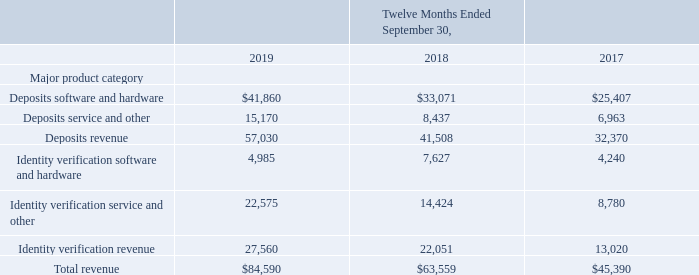Disaggregation of Revenue
The following table presents the Company's revenue disaggregated by major product category (amounts in thousands):
Software and hardware revenue is generated from on premise software license sales, as well as sales of hardware scanner boxes and on premise appliance products. Service and other revenue is generated from the sale of transactional SaaS products and services, maintenance associated with the sale of software and hardware, and consulting and professional services.
How is software and hardware revenue generated from? On premise software license sales, as well as sales of hardware scanner boxes and on premise appliance products. What is the value of Deposits software and hardware in fiscal 2019?
Answer scale should be: thousand. $41,860. What is the total revenue in the fiscal year 2018?
Answer scale should be: thousand. $63,559. What is the average of the Company’s total revenue from 2017 to 2019?
Answer scale should be: thousand. (45,390+63,559+84,590)/3 
Answer: 64513. What is the proportion of deposits revenue over total revenue in 2017? 32,370/45,390 
Answer: 0.71. Which year had the greatest amount of total revenue? 84,590> 63,559> 45,390
Answer: 2019. 